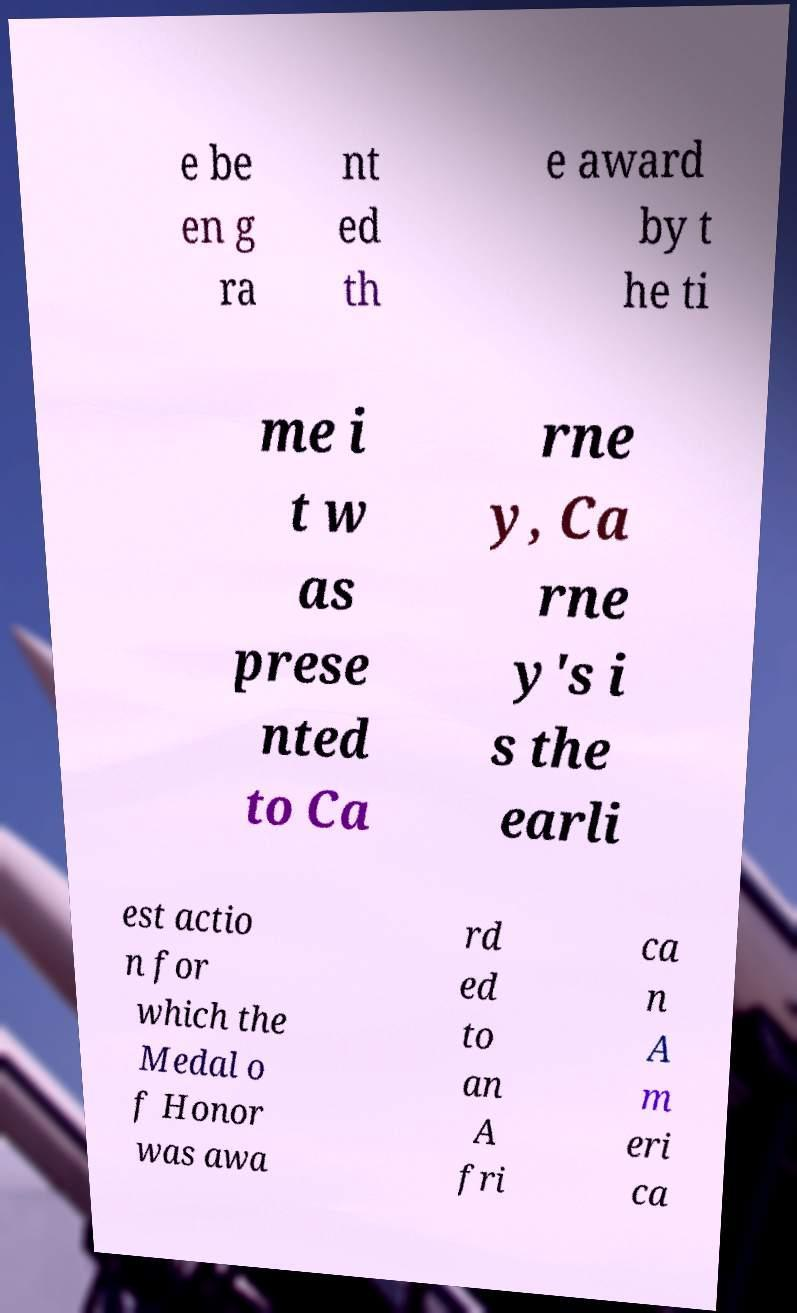Please identify and transcribe the text found in this image. e be en g ra nt ed th e award by t he ti me i t w as prese nted to Ca rne y, Ca rne y's i s the earli est actio n for which the Medal o f Honor was awa rd ed to an A fri ca n A m eri ca 